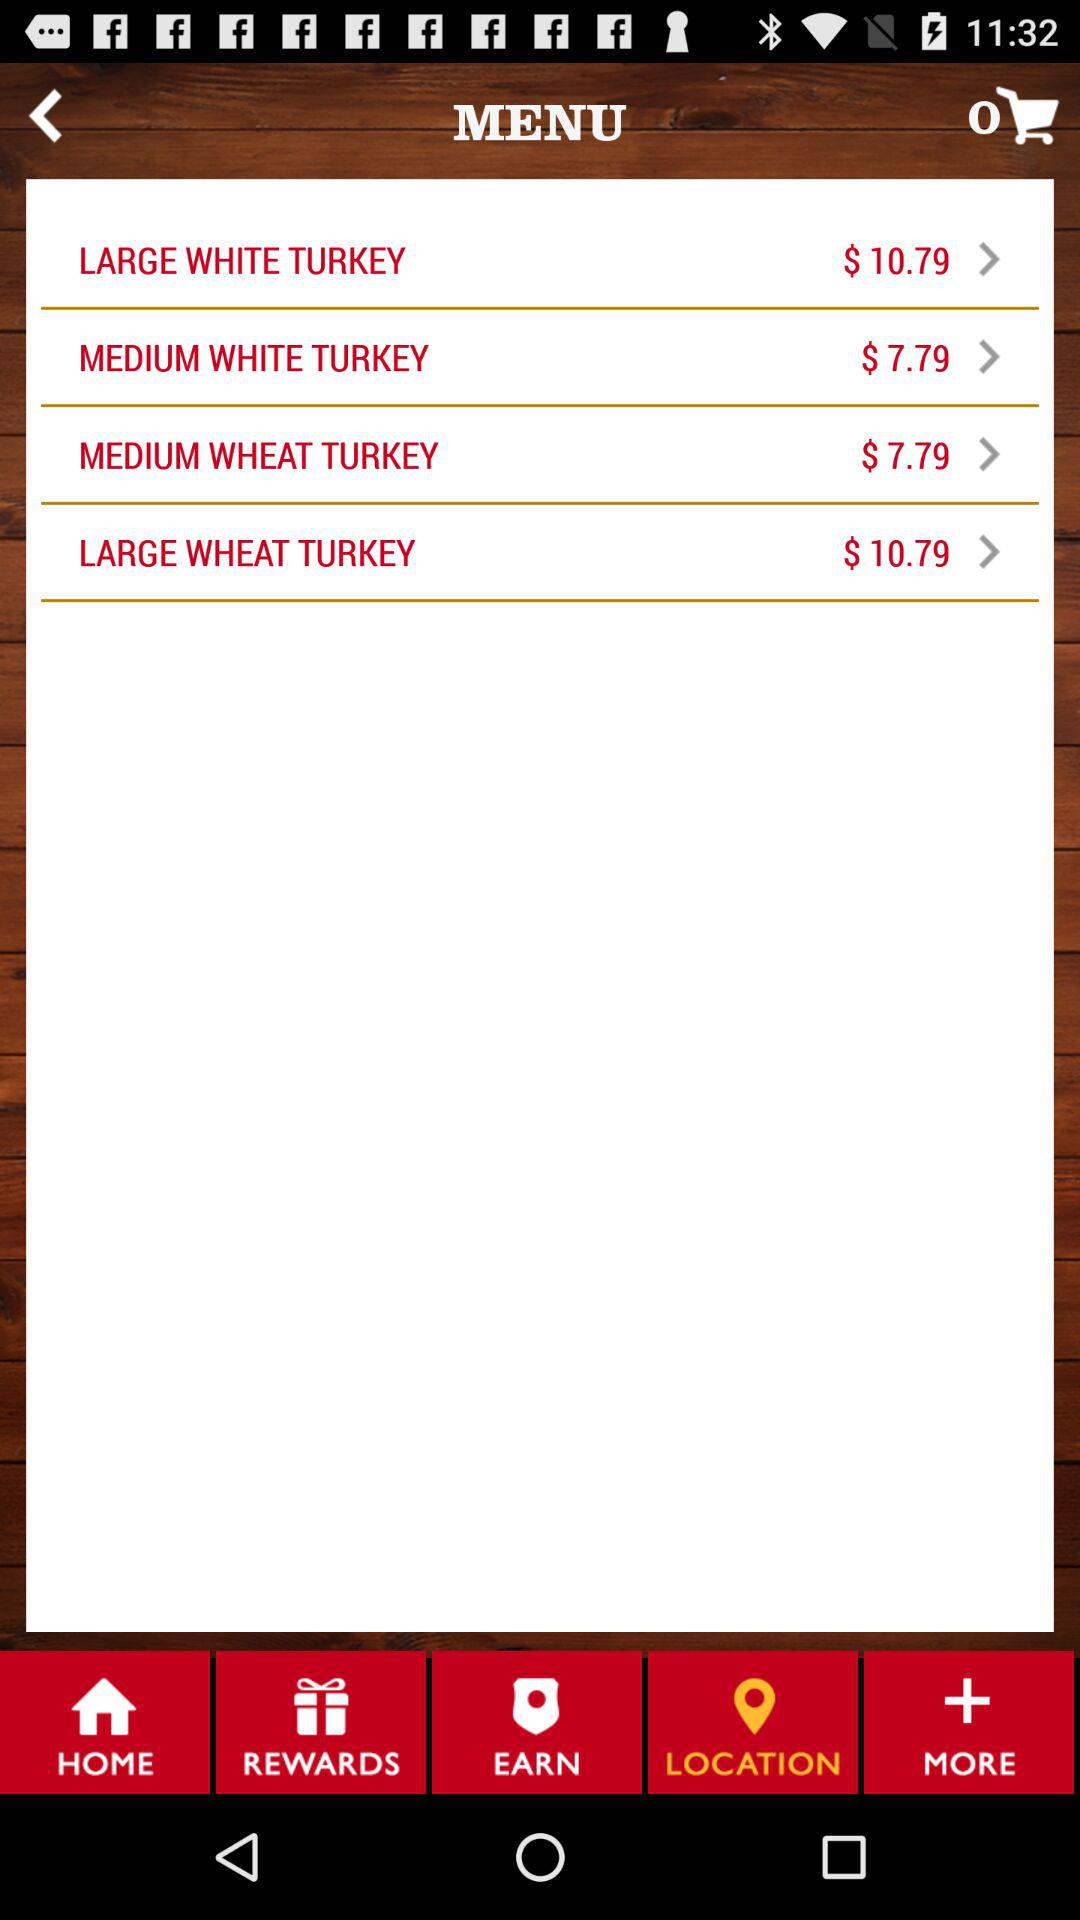How much more does the large wheat turkey cost than the medium white turkey?
Answer the question using a single word or phrase. $3.00 